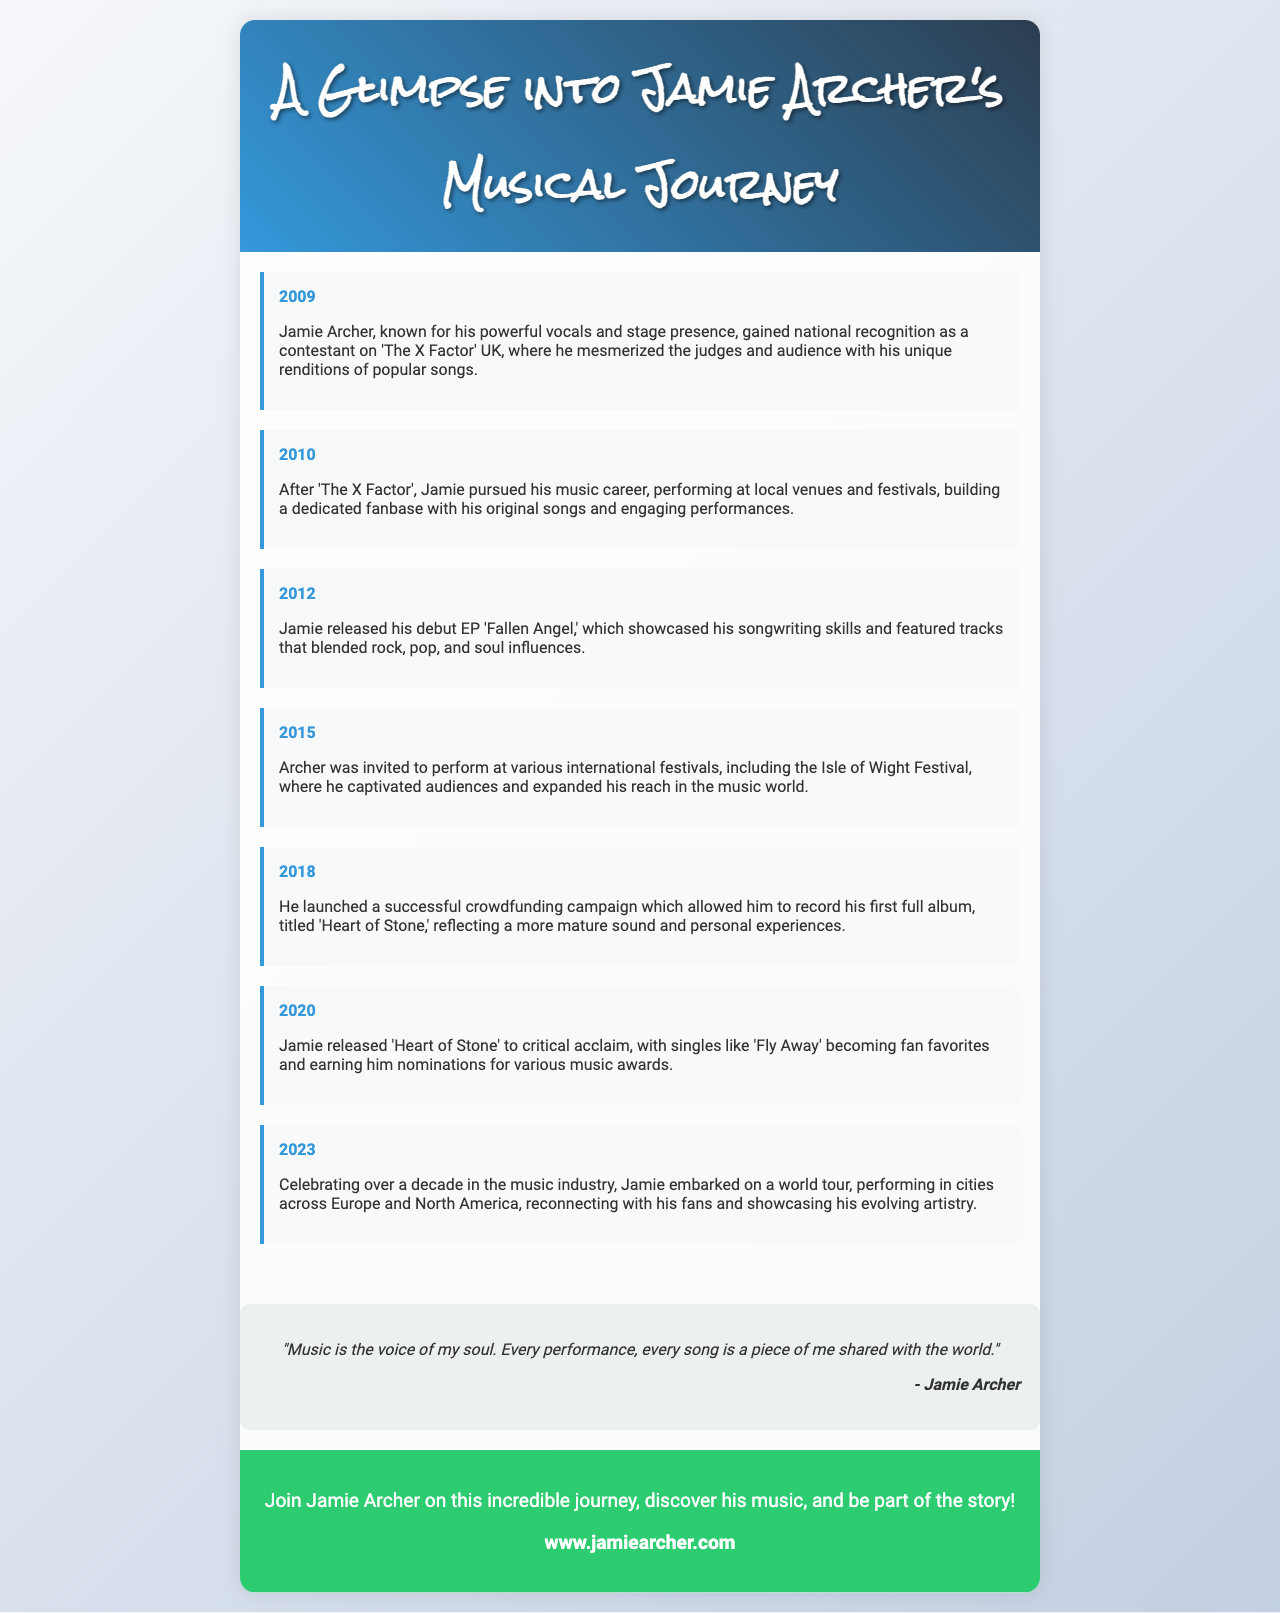What year did Jamie Archer gain national recognition on 'The X Factor'? The year when Jamie Archer gained national recognition on 'The X Factor' is explicitly stated in the document.
Answer: 2009 What is the title of Jamie Archer's debut EP? The title of Jamie's debut EP is mentioned in the document as part of his musical milestones.
Answer: Fallen Angel Which festival did Jamie perform at in 2015? The document lists various events, including a specific festival where Jamie performed in 2015.
Answer: Isle of Wight Festival How many years has Jamie Archer been in the music industry as of 2023? By subtracting the initial year of national recognition (2009) from the current year, we can calculate the total years.
Answer: 14 What type of campaign did Jamie launch in 2018? The document describes the nature of the campaign that Jamie launched to support his album recording.
Answer: Crowdfunding What is a key theme of the album 'Heart of Stone'? Key themes of Jamie's album are discussed in the context of personal experiences reflected in his work.
Answer: Personal experiences What genre influences are noted in Jamie's debut EP? The types of music that influenced Jamie's songwriting in his debut EP are specifically mentioned.
Answer: Rock, pop, and soul What is the website to join Jamie Archer's journey? The document includes a call-to-action with a specific website where fans can engage with Jamie's music.
Answer: www.jamiearcher.com What significant milestone did Jamie celebrate in 2023? The document highlights a major achievement for Jamie in 2023 related to his career.
Answer: Over a decade in the music industry 